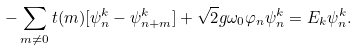<formula> <loc_0><loc_0><loc_500><loc_500>- \sum _ { { m } \neq 0 } t ( { m } ) [ \psi _ { n } ^ { k } - \psi _ { n + m } ^ { k } ] + \sqrt { 2 } g \omega _ { 0 } \varphi _ { n } \psi _ { n } ^ { k } = E _ { k } \psi _ { n } ^ { k } .</formula> 